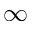Convert formula to latex. <formula><loc_0><loc_0><loc_500><loc_500>\infty</formula> 